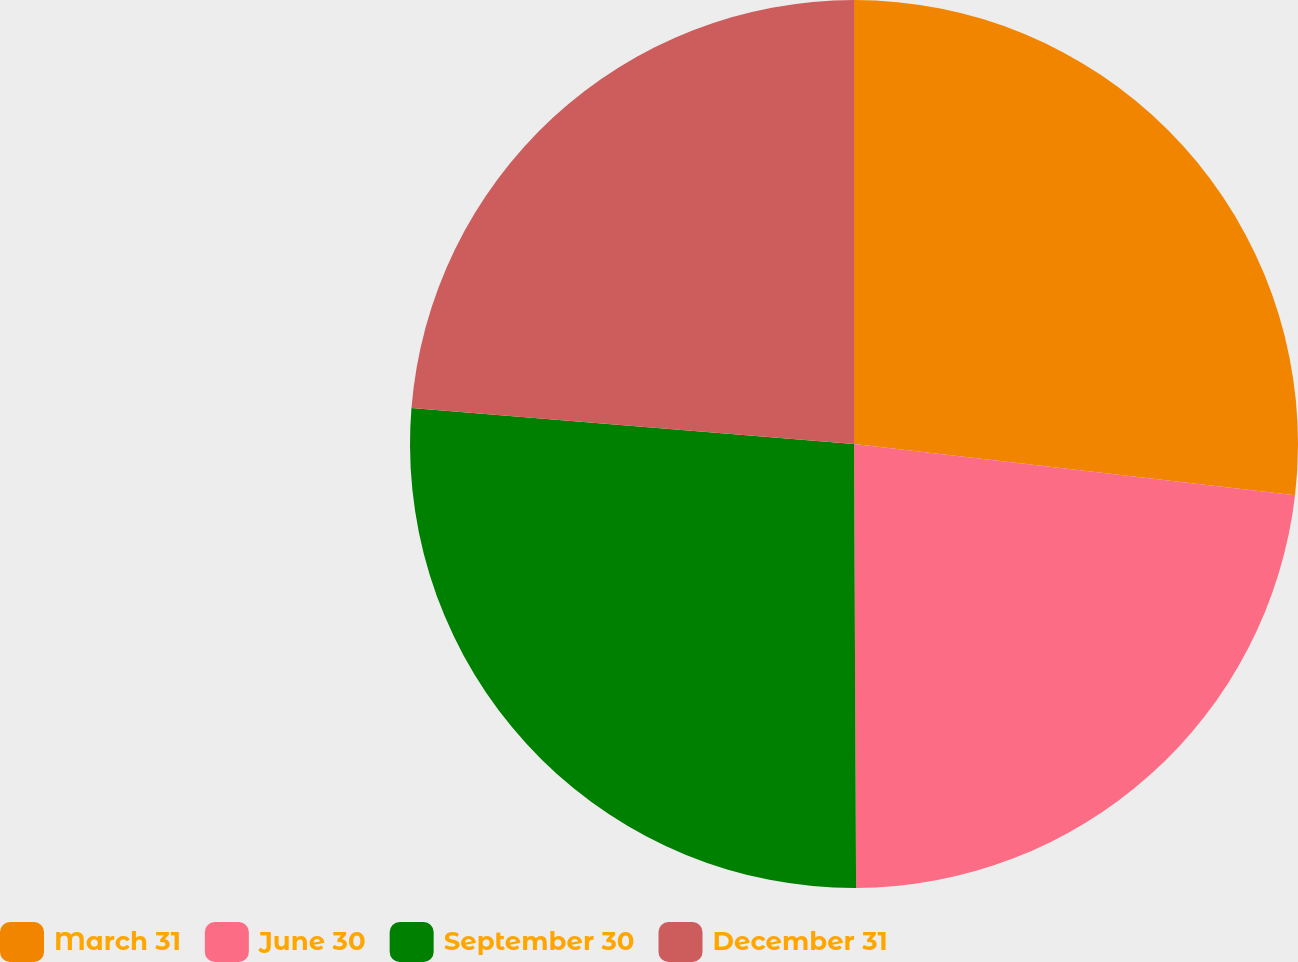Convert chart. <chart><loc_0><loc_0><loc_500><loc_500><pie_chart><fcel>March 31<fcel>June 30<fcel>September 30<fcel>December 31<nl><fcel>26.84%<fcel>23.09%<fcel>26.37%<fcel>23.71%<nl></chart> 